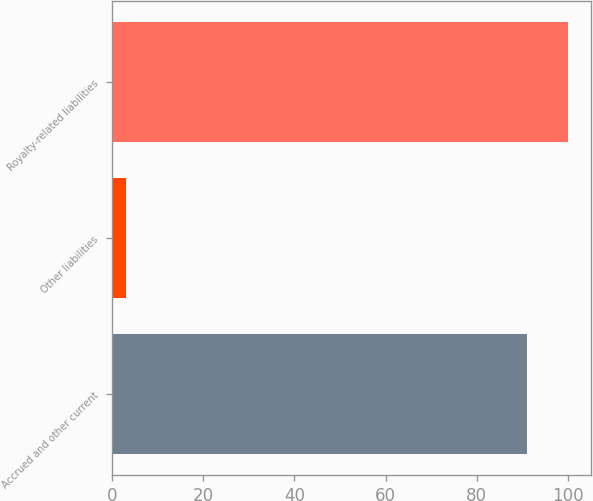Convert chart to OTSL. <chart><loc_0><loc_0><loc_500><loc_500><bar_chart><fcel>Accrued and other current<fcel>Other liabilities<fcel>Royalty-related liabilities<nl><fcel>91<fcel>3<fcel>100.1<nl></chart> 